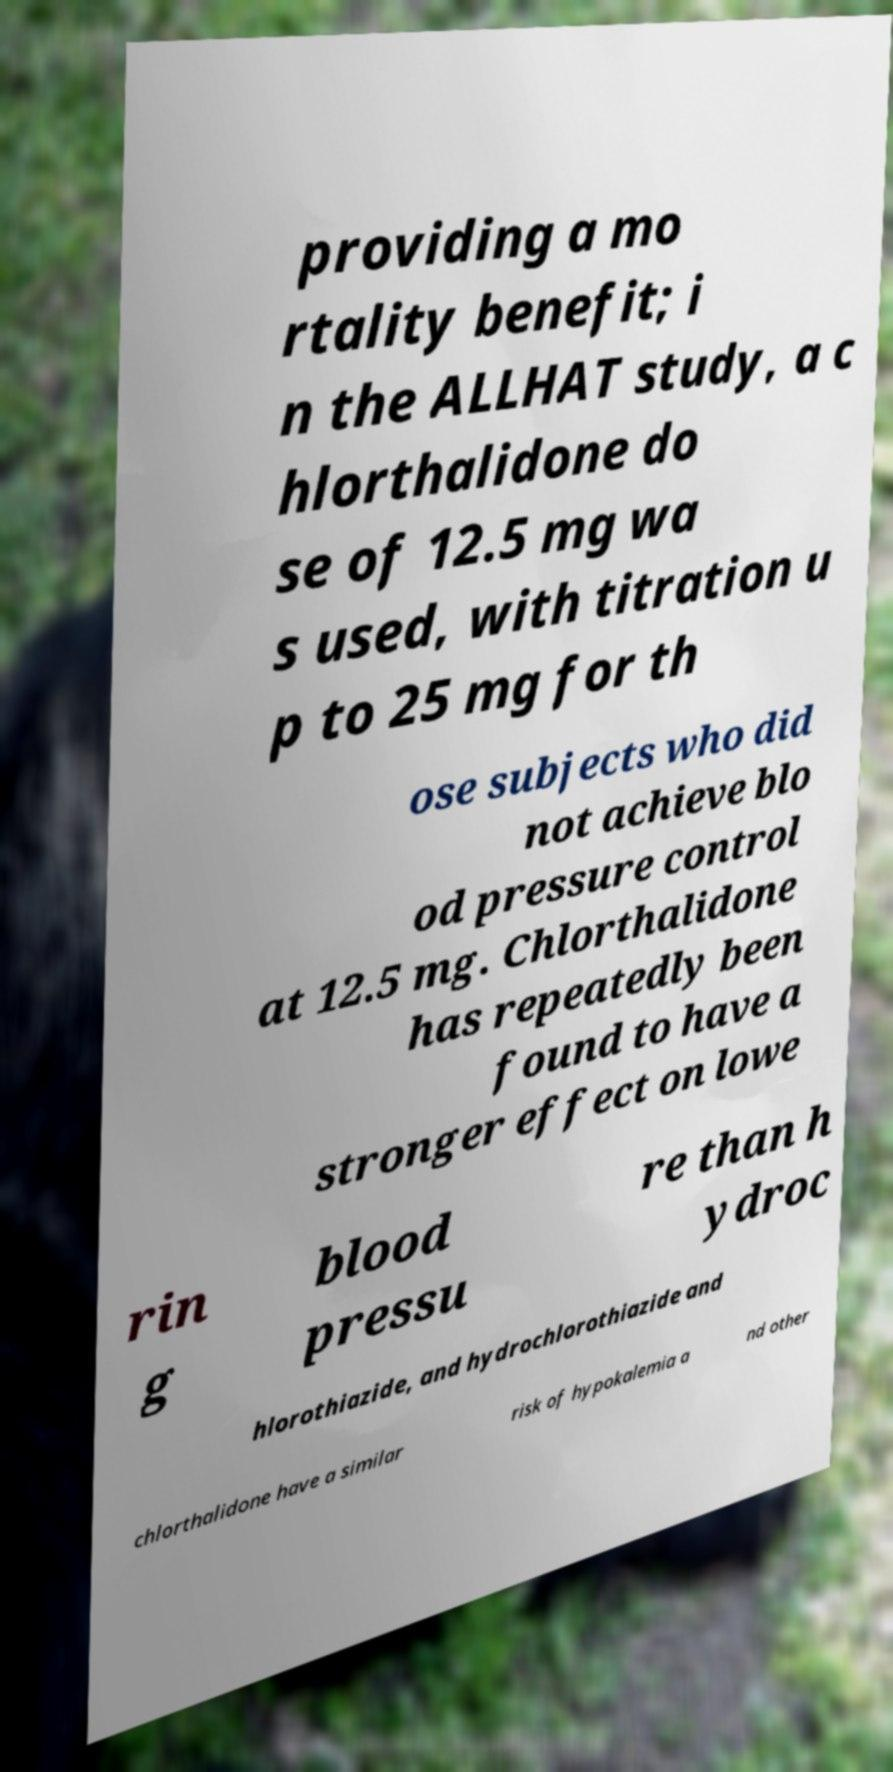Can you accurately transcribe the text from the provided image for me? providing a mo rtality benefit; i n the ALLHAT study, a c hlorthalidone do se of 12.5 mg wa s used, with titration u p to 25 mg for th ose subjects who did not achieve blo od pressure control at 12.5 mg. Chlorthalidone has repeatedly been found to have a stronger effect on lowe rin g blood pressu re than h ydroc hlorothiazide, and hydrochlorothiazide and chlorthalidone have a similar risk of hypokalemia a nd other 